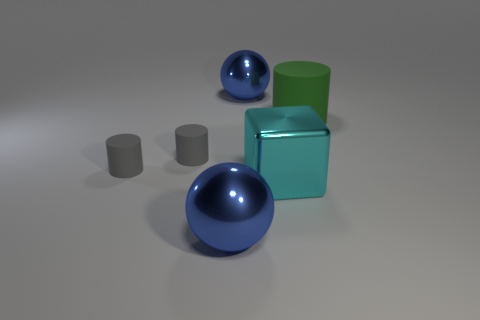There is a green rubber thing; is it the same size as the blue metallic object that is in front of the big cyan metallic thing?
Make the answer very short. Yes. What number of matte objects are large cyan things or small objects?
Provide a succinct answer. 2. How many tiny matte objects have the same shape as the large rubber thing?
Make the answer very short. 2. There is a sphere that is in front of the green matte thing; is its size the same as the metallic ball behind the large green matte cylinder?
Offer a very short reply. Yes. The blue shiny object in front of the big rubber cylinder has what shape?
Make the answer very short. Sphere. There is a large cyan metallic block; how many blue spheres are behind it?
Your answer should be compact. 1. Is the number of large cyan metal objects that are in front of the cyan shiny block less than the number of large shiny spheres that are behind the big green rubber cylinder?
Offer a very short reply. Yes. What number of purple objects are there?
Offer a very short reply. 0. There is a big sphere that is in front of the large green matte cylinder; what color is it?
Provide a succinct answer. Blue. What size is the cyan metallic thing?
Ensure brevity in your answer.  Large. 